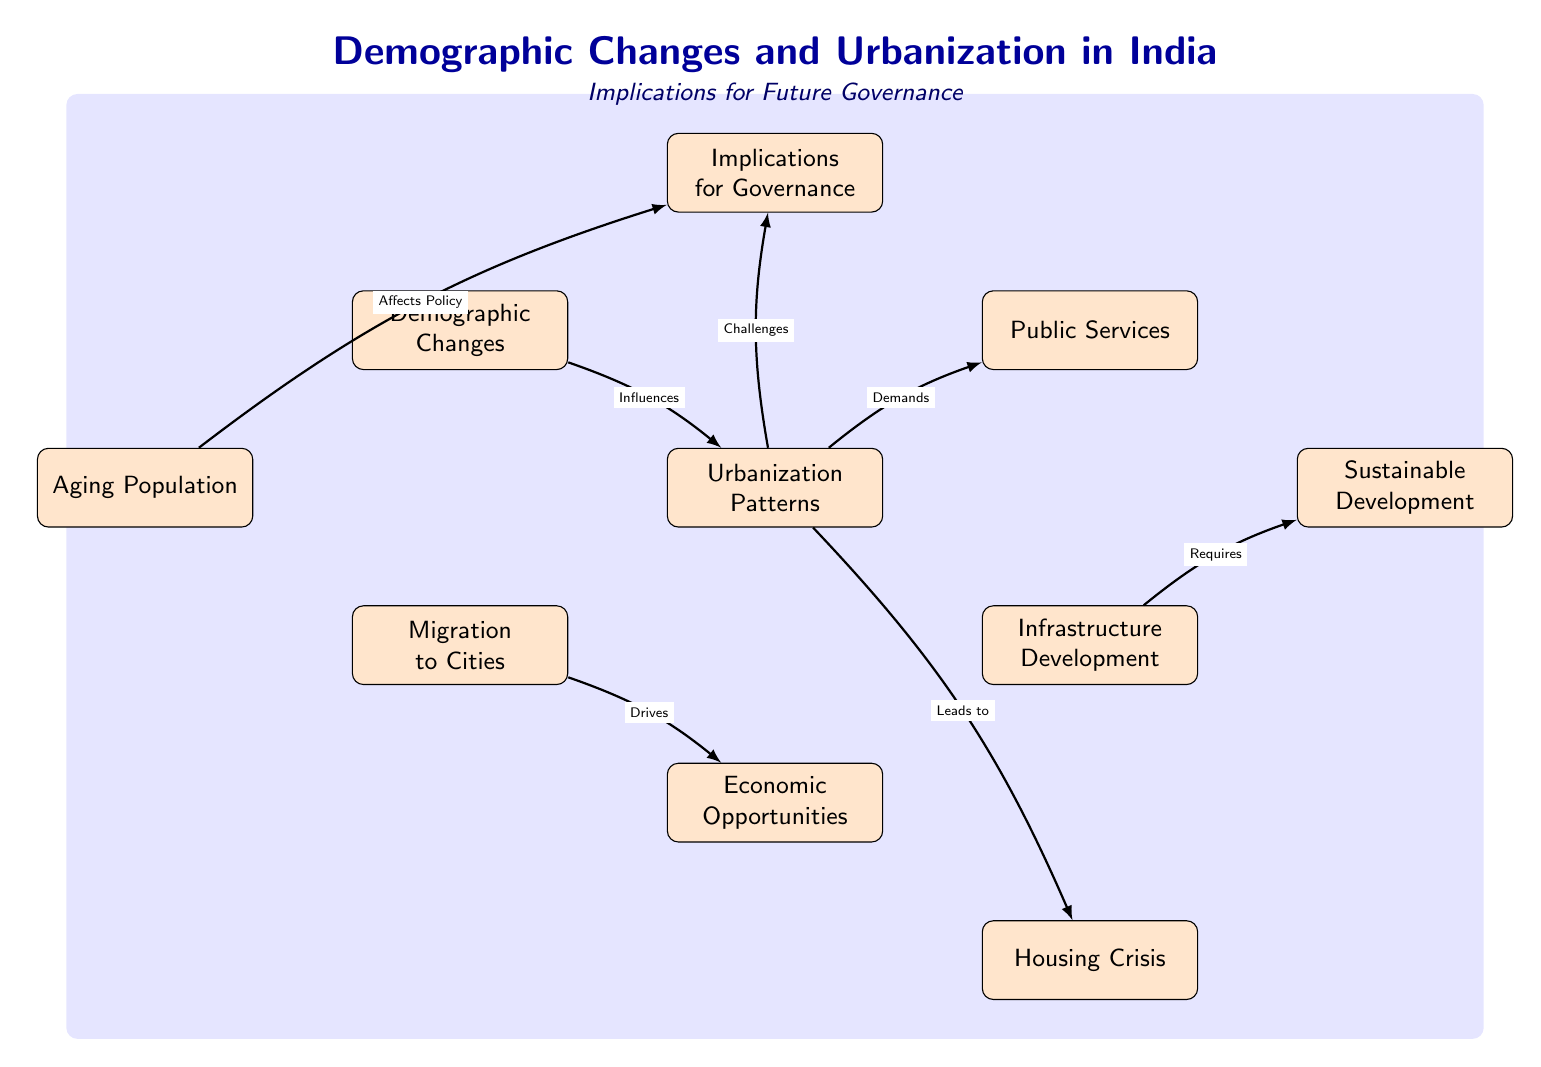What are the three main nodes related to demographic changes in the diagram? The three main nodes connected to demographic changes are Aging Population, Migration to Cities, and Economic Opportunities. They are directly related to demographic changes as indicated by their placement and connections in the diagram.
Answer: Aging Population, Migration to Cities, Economic Opportunities How many nodes are present in the diagram? The diagram features a total of ten nodes, which are visual representations of concepts related to demographic changes and urbanization patterns in India.
Answer: Ten Which node is influenced by demographic changes? The node "Urbanization Patterns" is influenced by the node "Demographic Changes" as indicated by the directed edge showing the influence relationship.
Answer: Urbanization Patterns What does "Migration to Cities" drive? "Migration to Cities" drives the node "Economic Opportunities," suggesting that urban migration is linked to increased economic prospects. This is shown by the connecting edge labeled "Drives."
Answer: Economic Opportunities Which node requires infrastructure development? The node "Sustainable Development" requires "Infrastructure Development." This is derived from the directed edge that states the need for infrastructure to achieve sustainability.
Answer: Infrastructure Development How do urbanization patterns challenge governance? Urbanization Patterns challenge governance by creating demands for public services and infrastructure, requiring effective management of urban growth. The connections from the Urbanization Patterns node demonstrate these challenges clearly.
Answer: Challenges What is indicated as a consequence of urbanization patterns? "Housing Crisis" is indicated as a consequence of urbanization patterns, which suggests that rapid urbanization can lead to issues with available housing as illustrated by the directed edge from Urbanization Patterns.
Answer: Housing Crisis What affects policy according to the diagram? The node "Aging Population" affects policy which implies that the demographic trend of aging requires governance adaptations to address its implications, marked by the connecting edge labeled "Affects Policy."
Answer: Affects Policy 